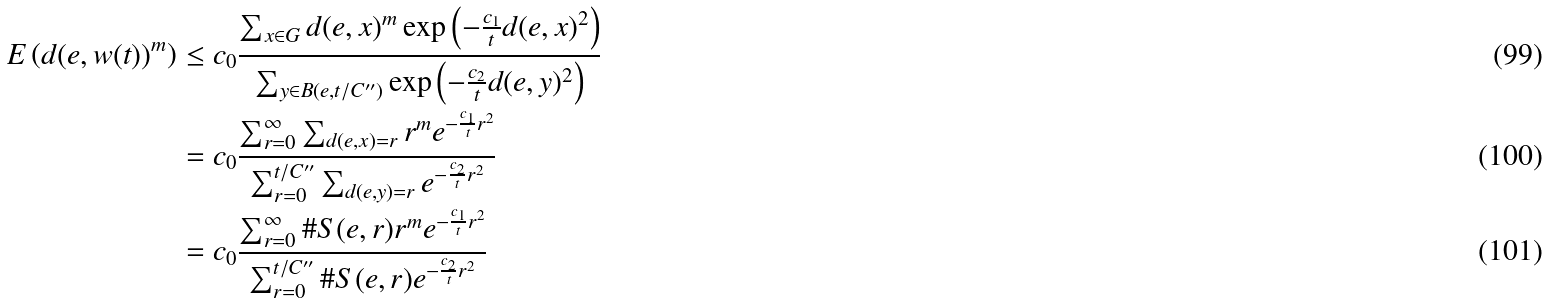<formula> <loc_0><loc_0><loc_500><loc_500>E \left ( d ( e , w ( t ) ) ^ { m } \right ) & \leq c _ { 0 } \frac { \sum _ { x \in G } d ( e , x ) ^ { m } \exp \left ( - \frac { c _ { 1 } } { t } d ( e , x ) ^ { 2 } \right ) } { \sum _ { y \in B ( e , t / C ^ { \prime \prime } ) } \exp \left ( - \frac { c _ { 2 } } { t } d ( e , y ) ^ { 2 } \right ) } \\ & = c _ { 0 } \frac { \sum _ { r = 0 } ^ { \infty } \sum _ { d ( e , x ) = r } r ^ { m } e ^ { - \frac { c _ { 1 } } { t } r ^ { 2 } } } { \sum _ { r = 0 } ^ { t / C ^ { \prime \prime } } \sum _ { d ( e , y ) = r } e ^ { - \frac { c _ { 2 } } { t } r ^ { 2 } } } \\ & = c _ { 0 } \frac { \sum _ { r = 0 } ^ { \infty } \# S ( e , r ) r ^ { m } e ^ { - \frac { c _ { 1 } } { t } r ^ { 2 } } } { \sum _ { r = 0 } ^ { t / C ^ { \prime \prime } } \# S ( e , r ) e ^ { - \frac { c _ { 2 } } { t } r ^ { 2 } } }</formula> 